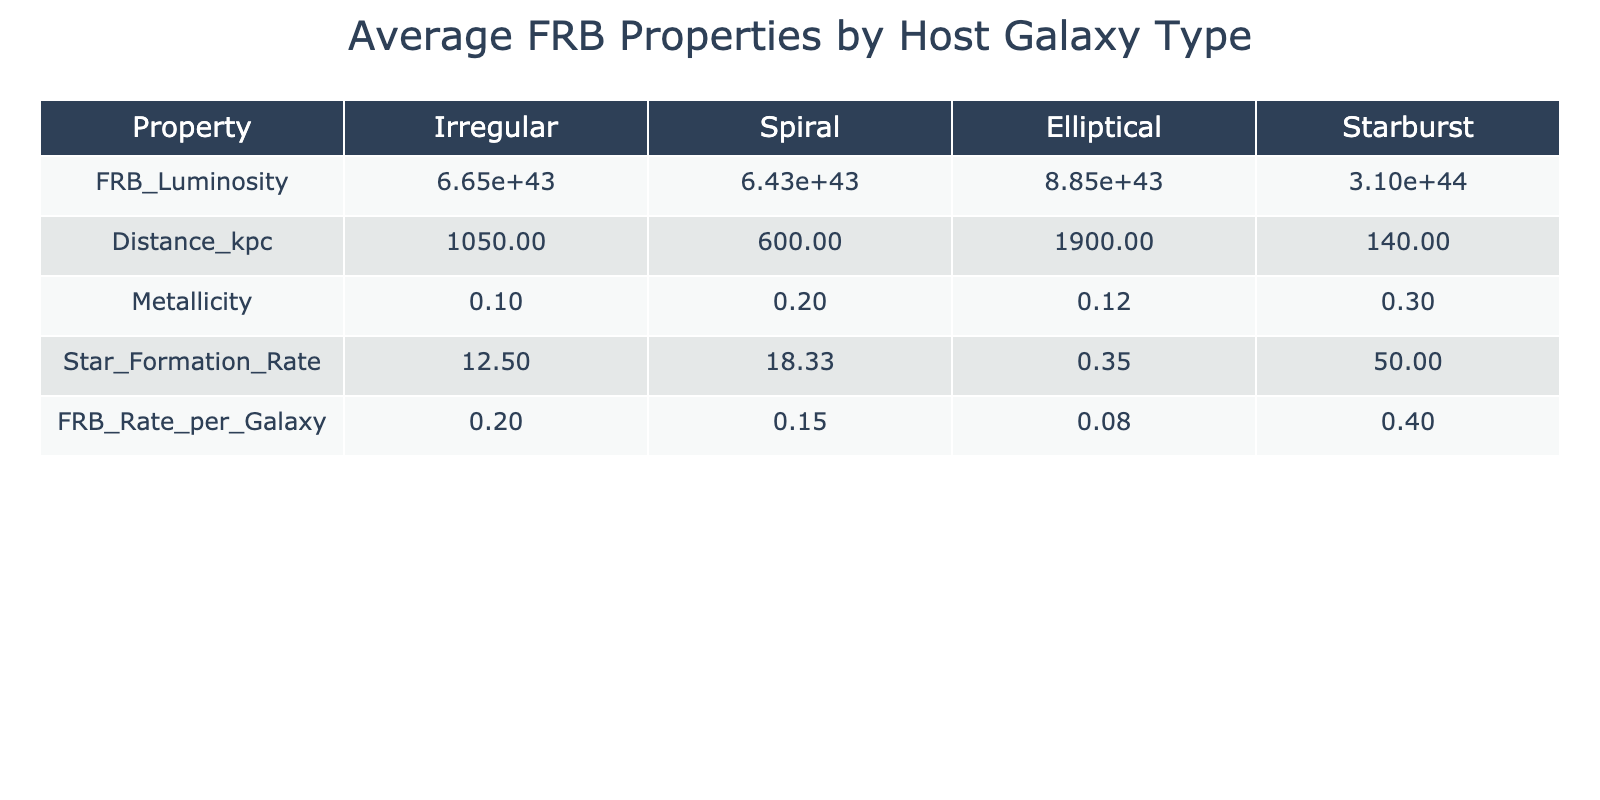What is the average FRB luminosity for spiral galaxies? The table shows that the average FRB luminosity for spiral galaxies is calculated by taking the mean of the two values: 1.2e+44 for FRB 180916.J0158+65 and 4.4e+43 for FRB 20190425A. This gives (1.2e+44 + 4.4e+43) / 2 = 7.0e+43
Answer: 7.0e+43 What is the FRB rate per galaxy for starburst galaxies? From the table, the FRB rate per galaxy for starburst galaxies is given directly as 0.4 from FRB200428.
Answer: 0.4 Which galaxy type has the highest average star formation rate? The average star formation rates listed are 10 for irregular, 5 for spiral, 0.5 for elliptical, and 50 for starburst. The highest value is 50 for starburst, indicating it has the highest average star formation rate.
Answer: Starburst What is the difference in average FRB luminosity between elliptical and irregular galaxies? The average FRB luminosity for elliptical galaxies is 8.4e+43 and for irregular galaxies is 6.65e+43. The difference is calculated as 8.4e+43 - 6.65e+43 = 1.75e+43.
Answer: 1.75e+43 Is the average distance for elliptical galaxies greater than for spiral galaxies? The average distances are 1900 kpc for elliptical galaxies and 773.33 kpc for spiral galaxies. Since 1900 > 773.33, the statement is true.
Answer: Yes What is the combined average metallicity of both irregular and starburst galaxies? The average metallicities are 0.1 for irregular and 0.3 for starburst. The combined average is calculated as (0.1 + 0.3) / 2 = 0.2.
Answer: 0.2 How many galaxy types have an average FRB rate per galaxy higher than 0.15? From the table, the average FRB rates for each galaxy type are: 0.2 for irregular, 0.1 for spiral, 0.05 for elliptical, and 0.4 for starburst. The types that exceed 0.15 are irregular and starburst. Thus, there are 2 galaxy types.
Answer: 2 Which galaxy type has the lowest average metallicity, and what is that value? The table lists the average metallicity as 0.05 for elliptical galaxies, which is lower than the other galaxy types (0.1 for irregular, 0.15 for spiral, and 0.3 for starburst). Thus, elliptical is the lowest.
Answer: Elliptical, 0.05 What would be the average distance if we considered only the host galaxies of FRBs below a luminosity of 1e+44? The applicable host galaxies are FRB 190523 (2000 kpc), FRB 20190520B (750 kpc), and FRB 20190425A (600 kpc). The total distance is 2000 + 750 + 600 = 3350 kpc, divided by 3 gives an average distance of 1116.67 kpc.
Answer: 1116.67 kpc 